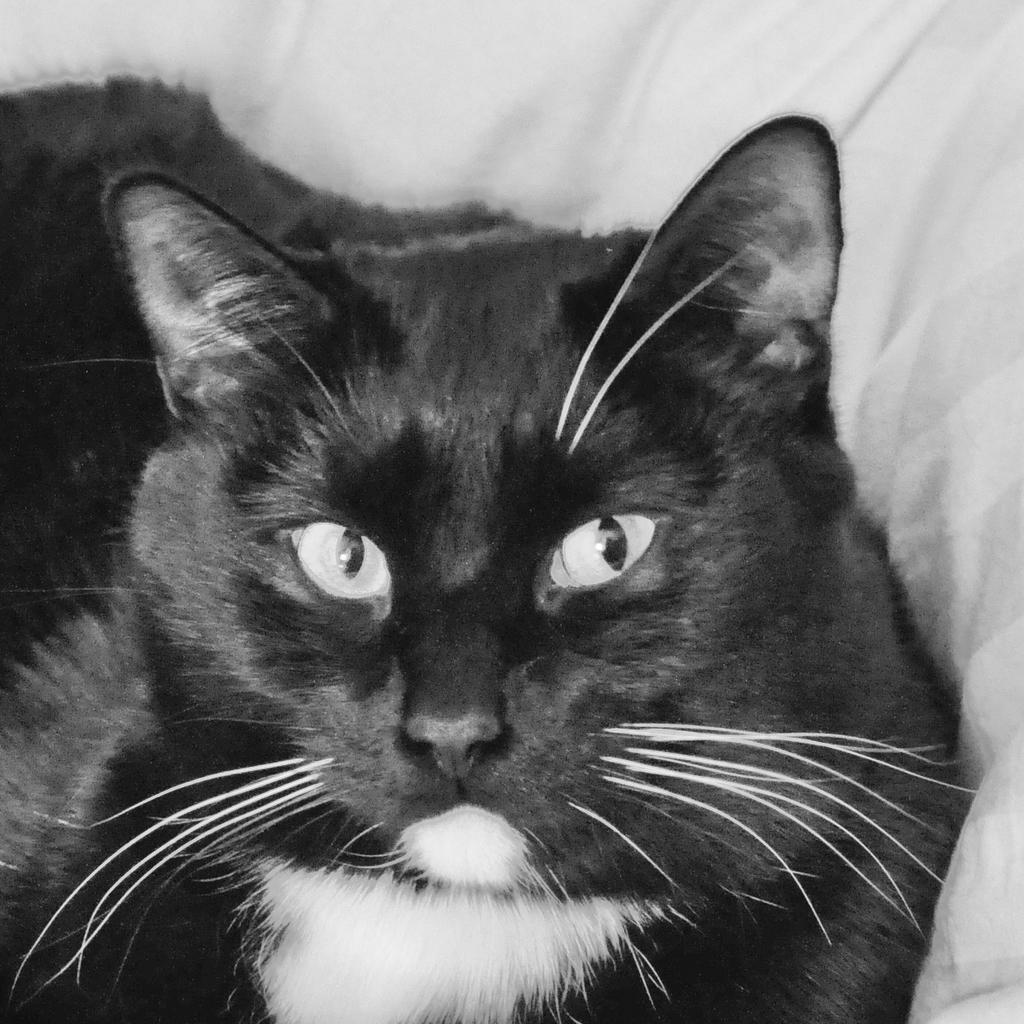Describe this image in one or two sentences. In this picture I can observe a cat. This is a black and white image. In the background I can observe cloth. 